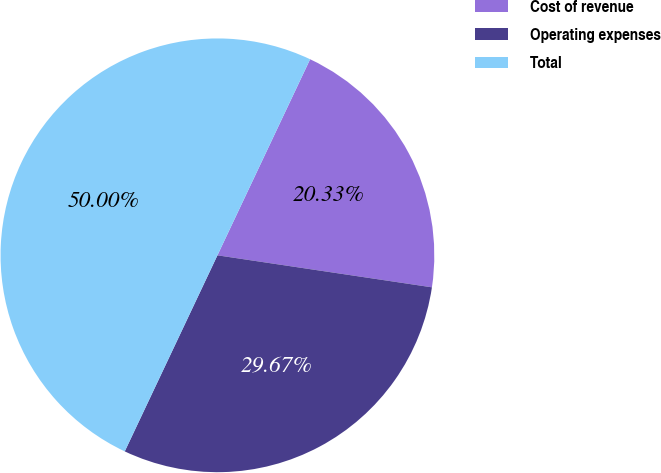Convert chart to OTSL. <chart><loc_0><loc_0><loc_500><loc_500><pie_chart><fcel>Cost of revenue<fcel>Operating expenses<fcel>Total<nl><fcel>20.33%<fcel>29.67%<fcel>50.0%<nl></chart> 